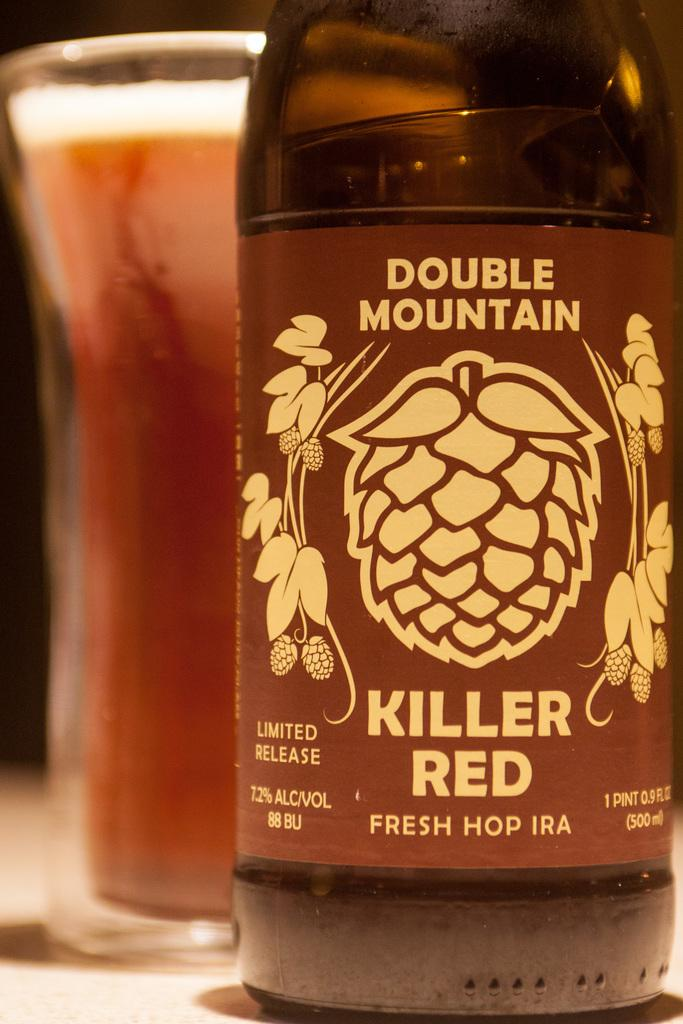<image>
Present a compact description of the photo's key features. A bottle of Double Mountain Killer Red Fresh Hop IPA stands next to a glass of beer. 